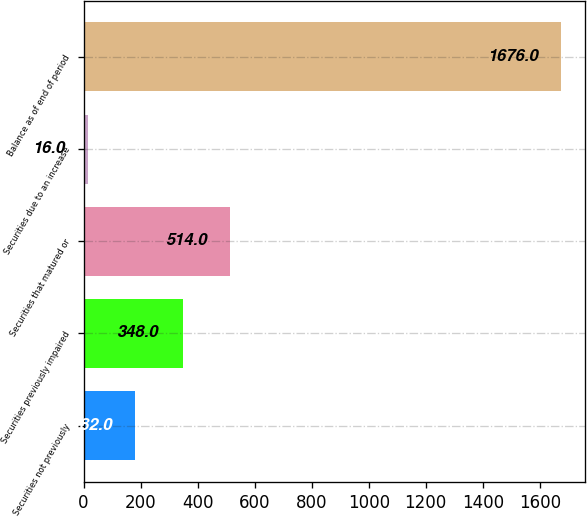Convert chart. <chart><loc_0><loc_0><loc_500><loc_500><bar_chart><fcel>Securities not previously<fcel>Securities previously impaired<fcel>Securities that matured or<fcel>Securities due to an increase<fcel>Balance as of end of period<nl><fcel>182<fcel>348<fcel>514<fcel>16<fcel>1676<nl></chart> 